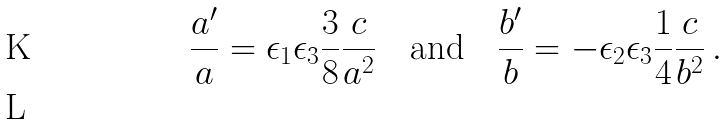Convert formula to latex. <formula><loc_0><loc_0><loc_500><loc_500>\frac { a ^ { \prime } } { a } = \epsilon _ { 1 } \epsilon _ { 3 } \frac { 3 } { 8 } \frac { c } { a ^ { 2 } } \quad \text {and} \quad \frac { b ^ { \prime } } { b } = - \epsilon _ { 2 } \epsilon _ { 3 } \frac { 1 } { 4 } \frac { c } { b ^ { 2 } } \, . \\</formula> 